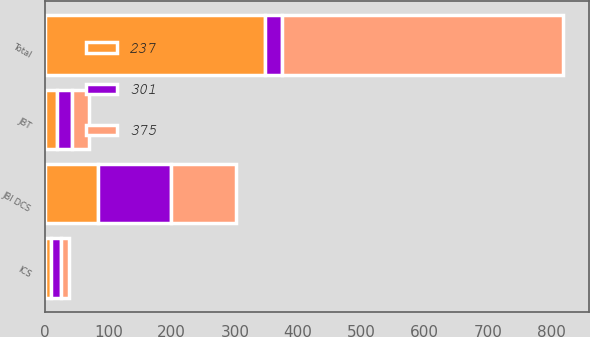Convert chart. <chart><loc_0><loc_0><loc_500><loc_500><stacked_bar_chart><ecel><fcel>JBI DCS<fcel>ICS<fcel>JBT<fcel>Total<nl><fcel>301<fcel>116<fcel>16<fcel>23<fcel>27<nl><fcel>375<fcel>103<fcel>13<fcel>27<fcel>444<nl><fcel>237<fcel>83<fcel>9<fcel>19<fcel>348<nl></chart> 